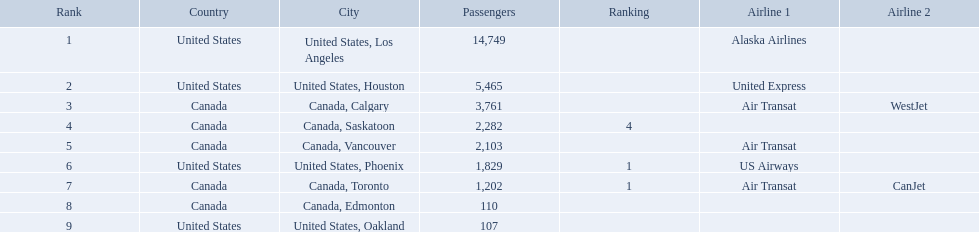What are all the cities? United States, Los Angeles, United States, Houston, Canada, Calgary, Canada, Saskatoon, Canada, Vancouver, United States, Phoenix, Canada, Toronto, Canada, Edmonton, United States, Oakland. How many passengers do they service? 14,749, 5,465, 3,761, 2,282, 2,103, 1,829, 1,202, 110, 107. Which city, when combined with los angeles, totals nearly 19,000? Canada, Calgary. What were all the passenger totals? 14,749, 5,465, 3,761, 2,282, 2,103, 1,829, 1,202, 110, 107. Which of these were to los angeles? 14,749. What other destination combined with this is closest to 19,000? Canada, Calgary. What are the cities that are associated with the playa de oro international airport? United States, Los Angeles, United States, Houston, Canada, Calgary, Canada, Saskatoon, Canada, Vancouver, United States, Phoenix, Canada, Toronto, Canada, Edmonton, United States, Oakland. What is uniteed states, los angeles passenger count? 14,749. Can you give me this table as a dict? {'header': ['Rank', 'Country', 'City', 'Passengers', 'Ranking', 'Airline 1', 'Airline 2'], 'rows': [['1', 'United States', 'United States, Los Angeles', '14,749', '', 'Alaska Airlines', ''], ['2', 'United States', 'United States, Houston', '5,465', '', 'United Express', ''], ['3', 'Canada', 'Canada, Calgary', '3,761', '', 'Air Transat', 'WestJet'], ['4', 'Canada', 'Canada, Saskatoon', '2,282', '4', '', ''], ['5', 'Canada', 'Canada, Vancouver', '2,103', '', 'Air Transat', ''], ['6', 'United States', 'United States, Phoenix', '1,829', '1', 'US Airways', ''], ['7', 'Canada', 'Canada, Toronto', '1,202', '1', 'Air Transat', 'CanJet'], ['8', 'Canada', 'Canada, Edmonton', '110', '', '', ''], ['9', 'United States', 'United States, Oakland', '107', '', '', '']]} What other cities passenger count would lead to 19,000 roughly when combined with previous los angeles? Canada, Calgary. What cities do the planes fly to? United States, Los Angeles, United States, Houston, Canada, Calgary, Canada, Saskatoon, Canada, Vancouver, United States, Phoenix, Canada, Toronto, Canada, Edmonton, United States, Oakland. How many people are flying to phoenix, arizona? 1,829. What are the cities flown to? United States, Los Angeles, United States, Houston, Canada, Calgary, Canada, Saskatoon, Canada, Vancouver, United States, Phoenix, Canada, Toronto, Canada, Edmonton, United States, Oakland. What number of passengers did pheonix have? 1,829. 